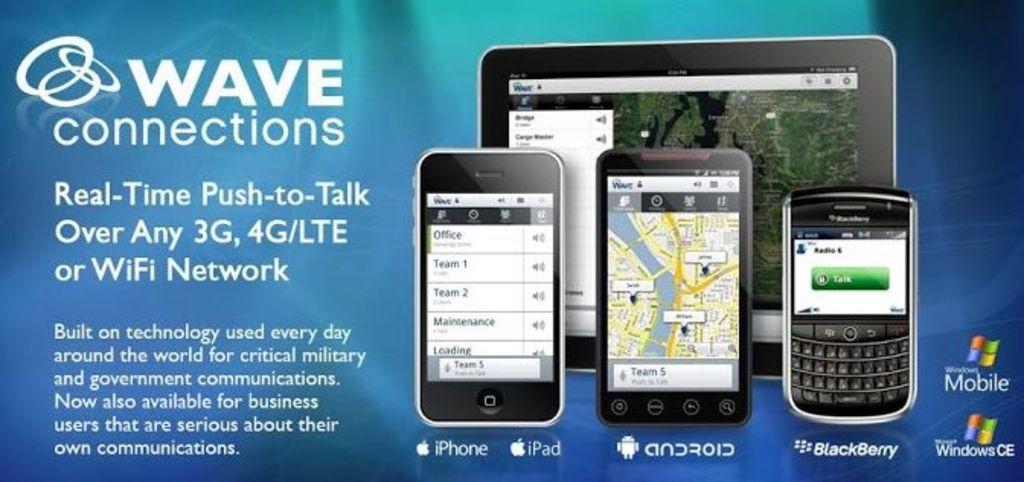What type of network with this work over?
Your response must be concise. 3g, 4g/lte, wifi. What kind of connections?
Ensure brevity in your answer.  Wave. 